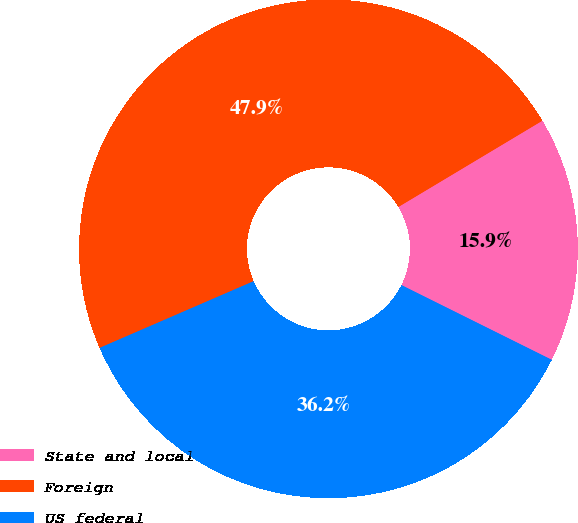Convert chart to OTSL. <chart><loc_0><loc_0><loc_500><loc_500><pie_chart><fcel>State and local<fcel>Foreign<fcel>US federal<nl><fcel>15.93%<fcel>47.91%<fcel>36.15%<nl></chart> 